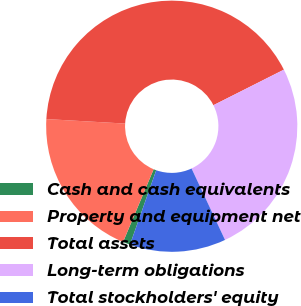<chart> <loc_0><loc_0><loc_500><loc_500><pie_chart><fcel>Cash and cash equivalents<fcel>Property and equipment net<fcel>Total assets<fcel>Long-term obligations<fcel>Total stockholders' equity<nl><fcel>0.94%<fcel>19.57%<fcel>41.66%<fcel>25.46%<fcel>12.37%<nl></chart> 